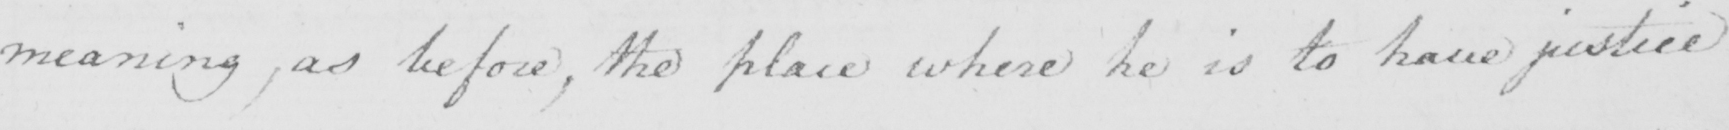What does this handwritten line say? meaning , as before , the place where he is to have justice 